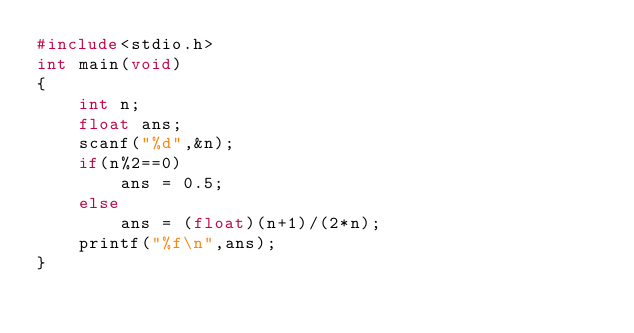<code> <loc_0><loc_0><loc_500><loc_500><_C_>#include<stdio.h>
int main(void)
{
    int n;
    float ans;
    scanf("%d",&n);
    if(n%2==0)
        ans = 0.5;
    else
        ans = (float)(n+1)/(2*n);
    printf("%f\n",ans);
}
</code> 